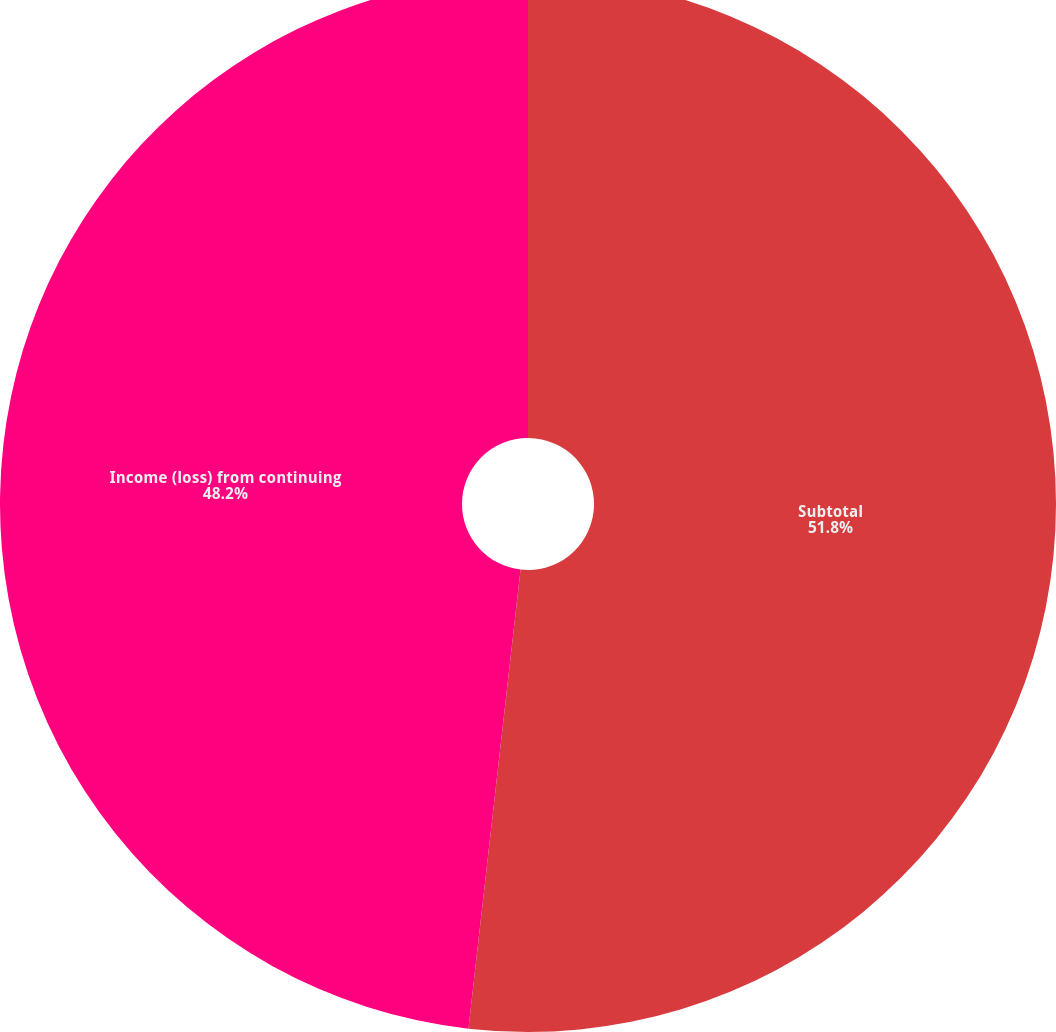Convert chart to OTSL. <chart><loc_0><loc_0><loc_500><loc_500><pie_chart><fcel>Subtotal<fcel>Income (loss) from continuing<nl><fcel>51.8%<fcel>48.2%<nl></chart> 